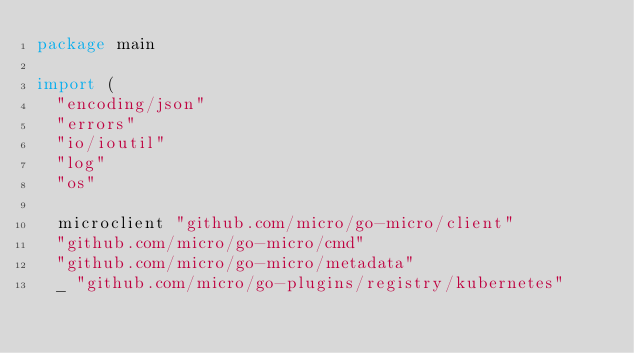<code> <loc_0><loc_0><loc_500><loc_500><_Go_>package main

import (
	"encoding/json"
	"errors"
	"io/ioutil"
	"log"
	"os"

	microclient "github.com/micro/go-micro/client"
	"github.com/micro/go-micro/cmd"
	"github.com/micro/go-micro/metadata"
	_ "github.com/micro/go-plugins/registry/kubernetes"
</code> 